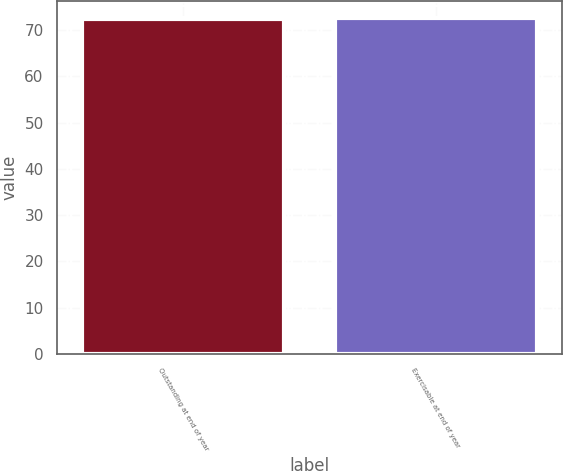Convert chart. <chart><loc_0><loc_0><loc_500><loc_500><bar_chart><fcel>Outstanding at end of year<fcel>Exercisable at end of year<nl><fcel>72.47<fcel>72.57<nl></chart> 